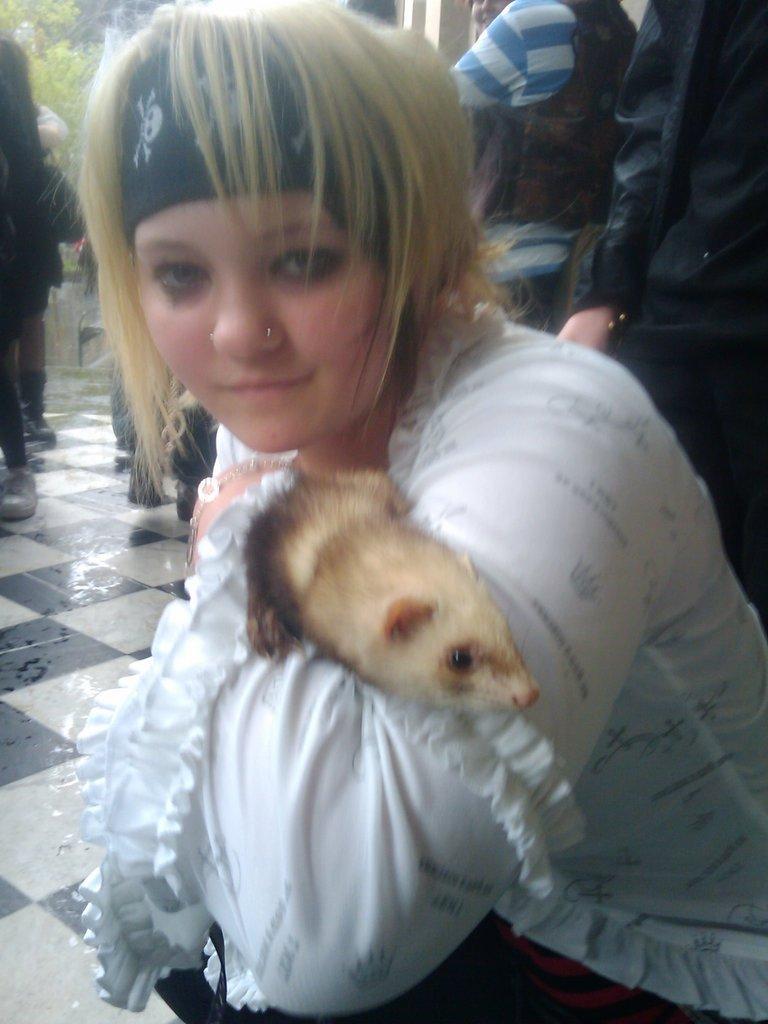In one or two sentences, can you explain what this image depicts? As we can see in the image there is a tree and few people standing and sitting here and there and the women who is sitting here is holding animal. 